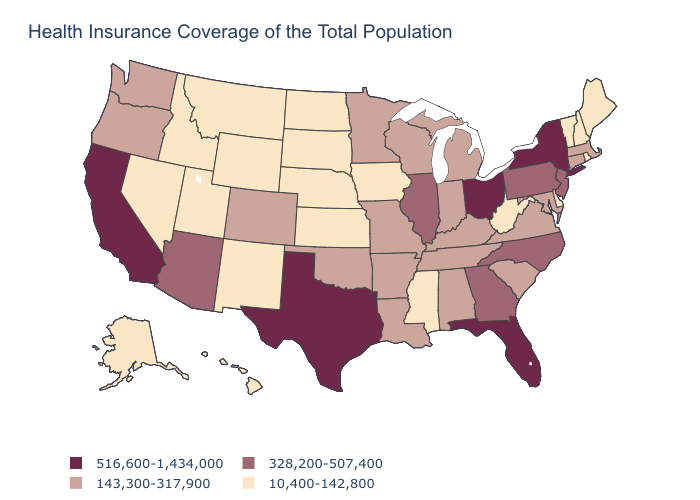How many symbols are there in the legend?
Concise answer only. 4. Does New Hampshire have the same value as Wisconsin?
Short answer required. No. Does the map have missing data?
Answer briefly. No. Name the states that have a value in the range 143,300-317,900?
Give a very brief answer. Alabama, Arkansas, Colorado, Connecticut, Indiana, Kentucky, Louisiana, Maryland, Massachusetts, Michigan, Minnesota, Missouri, Oklahoma, Oregon, South Carolina, Tennessee, Virginia, Washington, Wisconsin. What is the value of Utah?
Short answer required. 10,400-142,800. Name the states that have a value in the range 143,300-317,900?
Quick response, please. Alabama, Arkansas, Colorado, Connecticut, Indiana, Kentucky, Louisiana, Maryland, Massachusetts, Michigan, Minnesota, Missouri, Oklahoma, Oregon, South Carolina, Tennessee, Virginia, Washington, Wisconsin. Among the states that border Virginia , does West Virginia have the highest value?
Quick response, please. No. Is the legend a continuous bar?
Answer briefly. No. Which states have the lowest value in the USA?
Write a very short answer. Alaska, Delaware, Hawaii, Idaho, Iowa, Kansas, Maine, Mississippi, Montana, Nebraska, Nevada, New Hampshire, New Mexico, North Dakota, Rhode Island, South Dakota, Utah, Vermont, West Virginia, Wyoming. Name the states that have a value in the range 143,300-317,900?
Concise answer only. Alabama, Arkansas, Colorado, Connecticut, Indiana, Kentucky, Louisiana, Maryland, Massachusetts, Michigan, Minnesota, Missouri, Oklahoma, Oregon, South Carolina, Tennessee, Virginia, Washington, Wisconsin. Does Ohio have the highest value in the USA?
Short answer required. Yes. What is the lowest value in the Northeast?
Answer briefly. 10,400-142,800. Does Nevada have the lowest value in the USA?
Answer briefly. Yes. Name the states that have a value in the range 10,400-142,800?
Short answer required. Alaska, Delaware, Hawaii, Idaho, Iowa, Kansas, Maine, Mississippi, Montana, Nebraska, Nevada, New Hampshire, New Mexico, North Dakota, Rhode Island, South Dakota, Utah, Vermont, West Virginia, Wyoming. What is the value of Massachusetts?
Answer briefly. 143,300-317,900. 